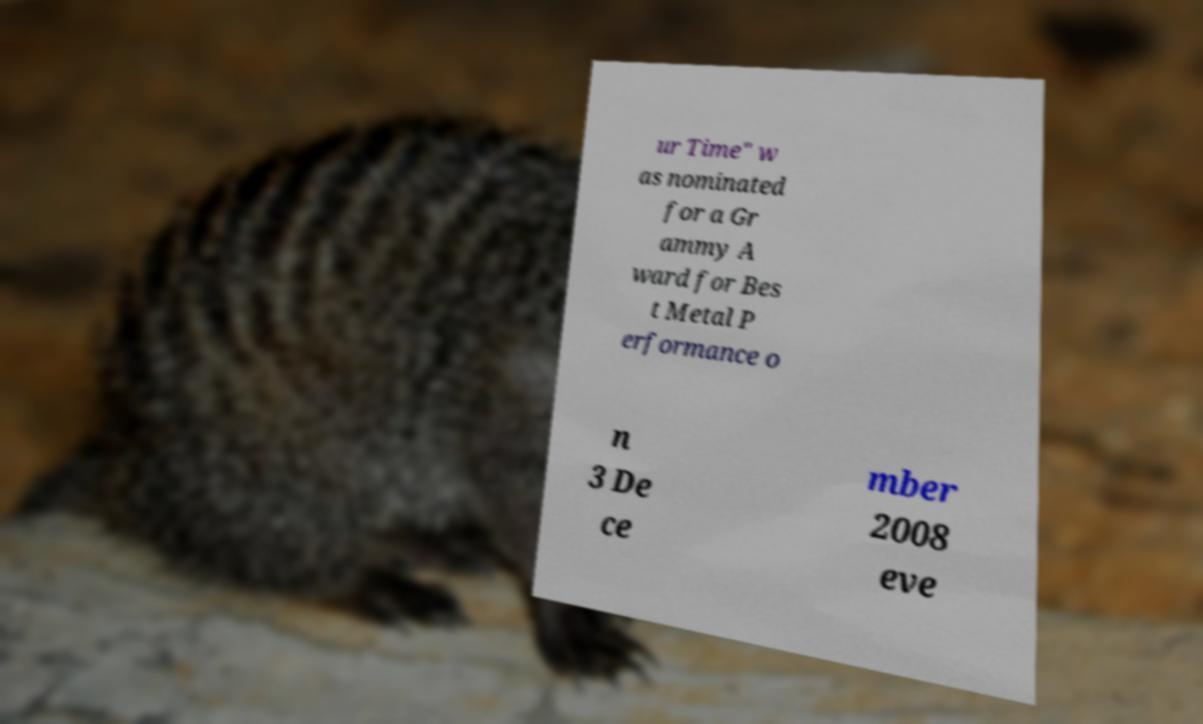For documentation purposes, I need the text within this image transcribed. Could you provide that? ur Time" w as nominated for a Gr ammy A ward for Bes t Metal P erformance o n 3 De ce mber 2008 eve 